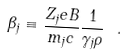<formula> <loc_0><loc_0><loc_500><loc_500>\beta _ { j } \equiv \frac { Z _ { j } e B } { m _ { j } c } \frac { 1 } { \gamma _ { j } \rho } \ .</formula> 